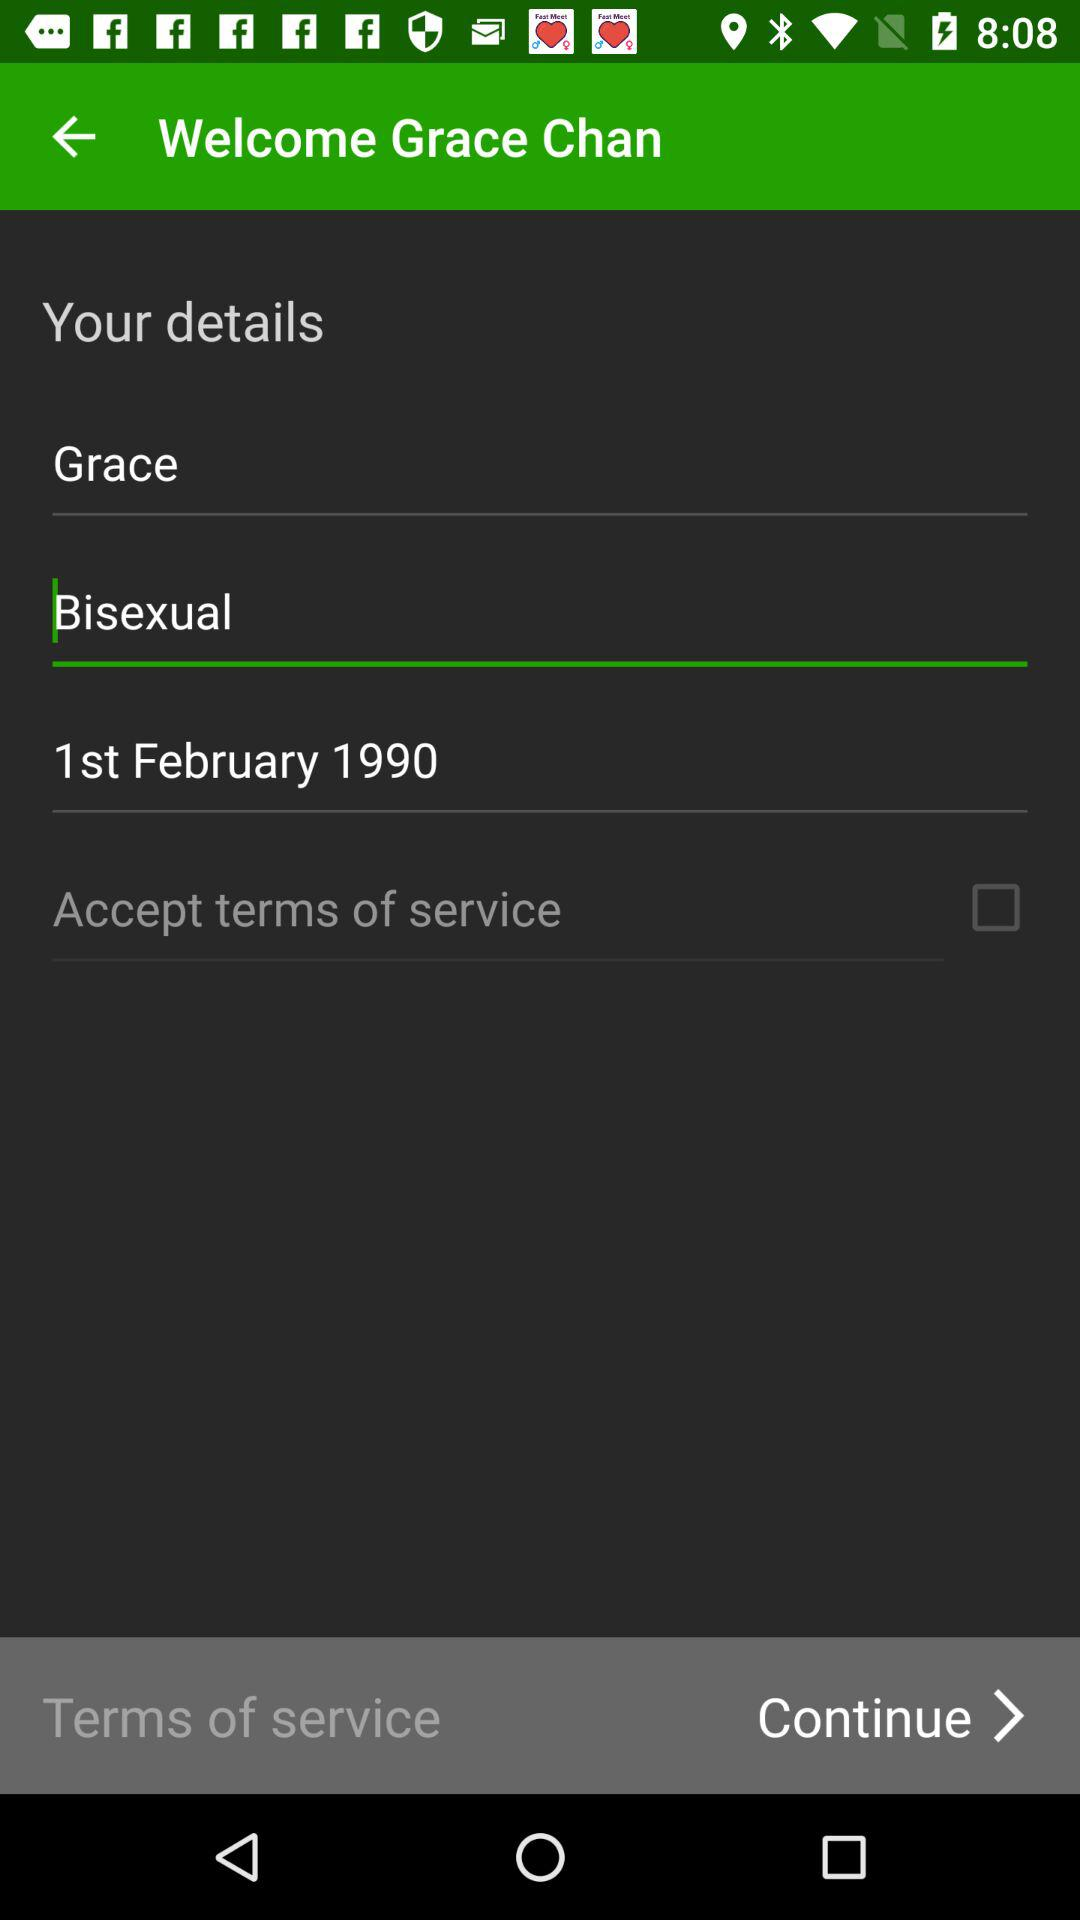What is the gender? The gender is bisexual. 